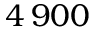Convert formula to latex. <formula><loc_0><loc_0><loc_500><loc_500>4 \, 9 0 0</formula> 